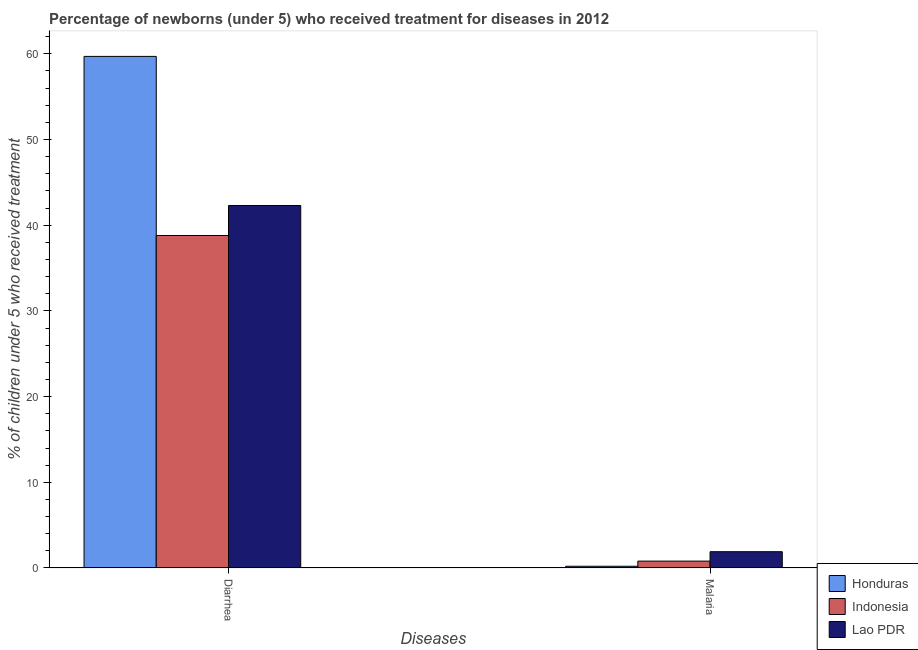What is the label of the 2nd group of bars from the left?
Give a very brief answer. Malaria. What is the percentage of children who received treatment for diarrhoea in Indonesia?
Your answer should be compact. 38.8. Across all countries, what is the maximum percentage of children who received treatment for diarrhoea?
Your response must be concise. 59.7. Across all countries, what is the minimum percentage of children who received treatment for diarrhoea?
Your response must be concise. 38.8. In which country was the percentage of children who received treatment for diarrhoea maximum?
Offer a terse response. Honduras. In which country was the percentage of children who received treatment for diarrhoea minimum?
Ensure brevity in your answer.  Indonesia. What is the difference between the percentage of children who received treatment for diarrhoea in Lao PDR and that in Indonesia?
Offer a very short reply. 3.5. What is the difference between the percentage of children who received treatment for malaria in Honduras and the percentage of children who received treatment for diarrhoea in Indonesia?
Give a very brief answer. -38.6. What is the average percentage of children who received treatment for malaria per country?
Make the answer very short. 0.97. What is the difference between the percentage of children who received treatment for malaria and percentage of children who received treatment for diarrhoea in Honduras?
Give a very brief answer. -59.5. What is the ratio of the percentage of children who received treatment for malaria in Lao PDR to that in Indonesia?
Your answer should be compact. 2.37. Is the percentage of children who received treatment for malaria in Indonesia less than that in Honduras?
Your answer should be very brief. No. What does the 3rd bar from the left in Diarrhea represents?
Offer a very short reply. Lao PDR. What is the difference between two consecutive major ticks on the Y-axis?
Give a very brief answer. 10. Are the values on the major ticks of Y-axis written in scientific E-notation?
Keep it short and to the point. No. Does the graph contain any zero values?
Offer a very short reply. No. How many legend labels are there?
Make the answer very short. 3. How are the legend labels stacked?
Give a very brief answer. Vertical. What is the title of the graph?
Provide a short and direct response. Percentage of newborns (under 5) who received treatment for diseases in 2012. Does "Turkmenistan" appear as one of the legend labels in the graph?
Keep it short and to the point. No. What is the label or title of the X-axis?
Your response must be concise. Diseases. What is the label or title of the Y-axis?
Provide a short and direct response. % of children under 5 who received treatment. What is the % of children under 5 who received treatment in Honduras in Diarrhea?
Offer a very short reply. 59.7. What is the % of children under 5 who received treatment of Indonesia in Diarrhea?
Make the answer very short. 38.8. What is the % of children under 5 who received treatment of Lao PDR in Diarrhea?
Keep it short and to the point. 42.3. What is the % of children under 5 who received treatment of Lao PDR in Malaria?
Your response must be concise. 1.9. Across all Diseases, what is the maximum % of children under 5 who received treatment of Honduras?
Keep it short and to the point. 59.7. Across all Diseases, what is the maximum % of children under 5 who received treatment in Indonesia?
Offer a very short reply. 38.8. Across all Diseases, what is the maximum % of children under 5 who received treatment of Lao PDR?
Make the answer very short. 42.3. Across all Diseases, what is the minimum % of children under 5 who received treatment of Honduras?
Make the answer very short. 0.2. Across all Diseases, what is the minimum % of children under 5 who received treatment in Indonesia?
Your response must be concise. 0.8. What is the total % of children under 5 who received treatment in Honduras in the graph?
Give a very brief answer. 59.9. What is the total % of children under 5 who received treatment of Indonesia in the graph?
Make the answer very short. 39.6. What is the total % of children under 5 who received treatment of Lao PDR in the graph?
Your answer should be compact. 44.2. What is the difference between the % of children under 5 who received treatment of Honduras in Diarrhea and that in Malaria?
Your answer should be very brief. 59.5. What is the difference between the % of children under 5 who received treatment in Lao PDR in Diarrhea and that in Malaria?
Provide a succinct answer. 40.4. What is the difference between the % of children under 5 who received treatment of Honduras in Diarrhea and the % of children under 5 who received treatment of Indonesia in Malaria?
Ensure brevity in your answer.  58.9. What is the difference between the % of children under 5 who received treatment in Honduras in Diarrhea and the % of children under 5 who received treatment in Lao PDR in Malaria?
Your answer should be very brief. 57.8. What is the difference between the % of children under 5 who received treatment in Indonesia in Diarrhea and the % of children under 5 who received treatment in Lao PDR in Malaria?
Ensure brevity in your answer.  36.9. What is the average % of children under 5 who received treatment of Honduras per Diseases?
Your answer should be compact. 29.95. What is the average % of children under 5 who received treatment of Indonesia per Diseases?
Provide a short and direct response. 19.8. What is the average % of children under 5 who received treatment of Lao PDR per Diseases?
Your answer should be compact. 22.1. What is the difference between the % of children under 5 who received treatment of Honduras and % of children under 5 who received treatment of Indonesia in Diarrhea?
Give a very brief answer. 20.9. What is the difference between the % of children under 5 who received treatment in Indonesia and % of children under 5 who received treatment in Lao PDR in Diarrhea?
Offer a terse response. -3.5. What is the difference between the % of children under 5 who received treatment of Honduras and % of children under 5 who received treatment of Lao PDR in Malaria?
Offer a terse response. -1.7. What is the ratio of the % of children under 5 who received treatment in Honduras in Diarrhea to that in Malaria?
Your answer should be very brief. 298.5. What is the ratio of the % of children under 5 who received treatment of Indonesia in Diarrhea to that in Malaria?
Give a very brief answer. 48.5. What is the ratio of the % of children under 5 who received treatment of Lao PDR in Diarrhea to that in Malaria?
Your response must be concise. 22.26. What is the difference between the highest and the second highest % of children under 5 who received treatment of Honduras?
Provide a succinct answer. 59.5. What is the difference between the highest and the second highest % of children under 5 who received treatment of Lao PDR?
Your answer should be compact. 40.4. What is the difference between the highest and the lowest % of children under 5 who received treatment of Honduras?
Provide a succinct answer. 59.5. What is the difference between the highest and the lowest % of children under 5 who received treatment of Indonesia?
Give a very brief answer. 38. What is the difference between the highest and the lowest % of children under 5 who received treatment in Lao PDR?
Offer a very short reply. 40.4. 